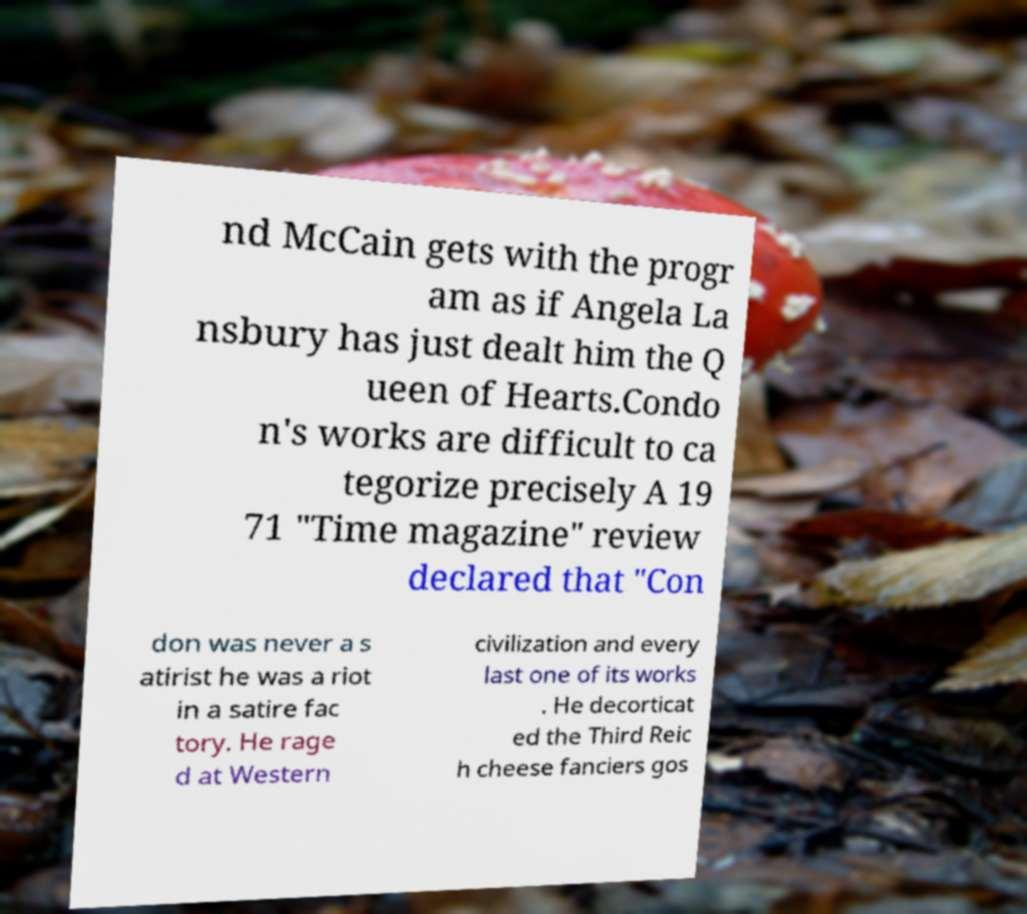For documentation purposes, I need the text within this image transcribed. Could you provide that? nd McCain gets with the progr am as if Angela La nsbury has just dealt him the Q ueen of Hearts.Condo n's works are difficult to ca tegorize precisely A 19 71 "Time magazine" review declared that "Con don was never a s atirist he was a riot in a satire fac tory. He rage d at Western civilization and every last one of its works . He decorticat ed the Third Reic h cheese fanciers gos 